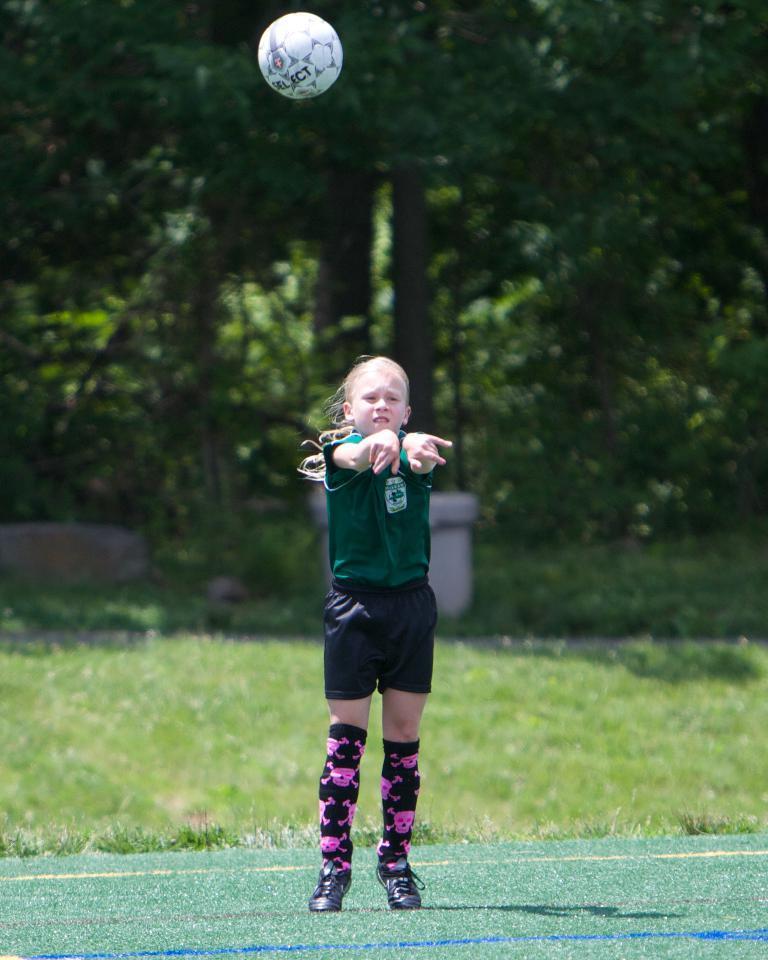Could you give a brief overview of what you see in this image? In this image I can see a person standing, wearing a green t shirt and black shorts. There is grass and trees at the back. There is a white ball at the top of the image. 